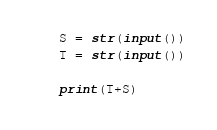<code> <loc_0><loc_0><loc_500><loc_500><_Python_>S = str(input())
T = str(input())

print(T+S)</code> 